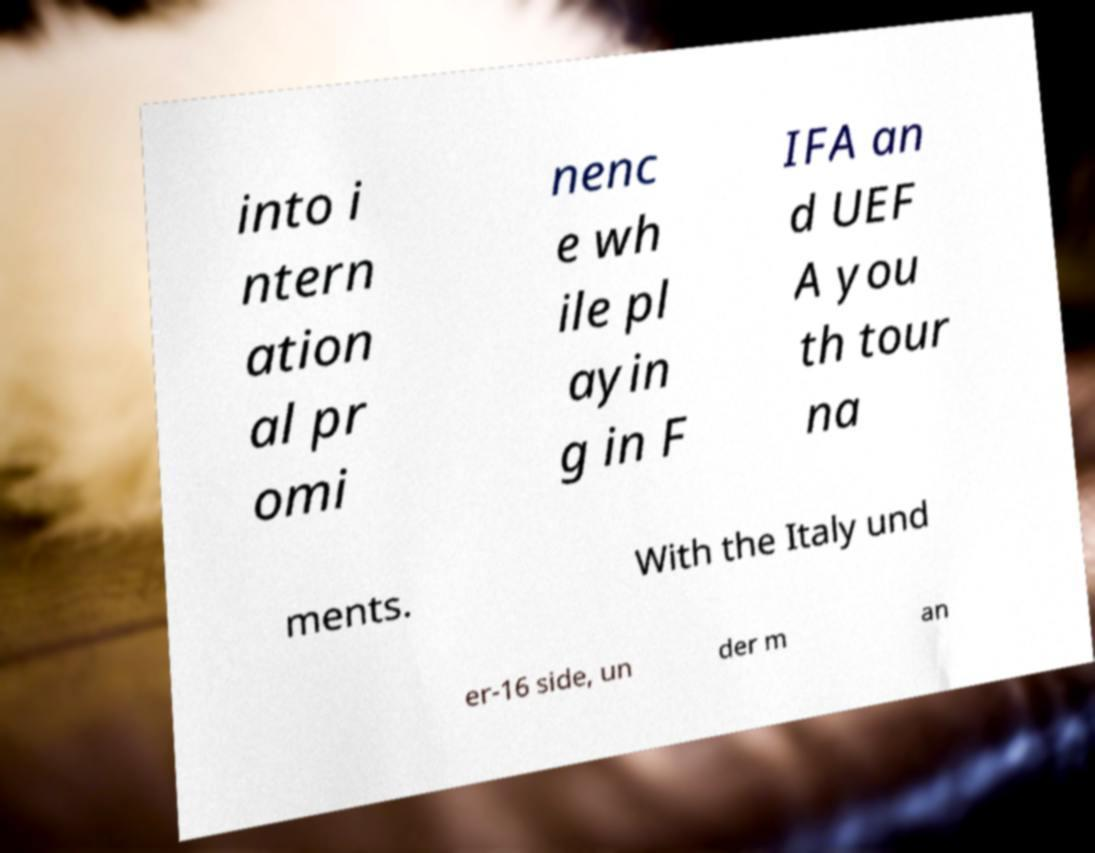There's text embedded in this image that I need extracted. Can you transcribe it verbatim? into i ntern ation al pr omi nenc e wh ile pl ayin g in F IFA an d UEF A you th tour na ments. With the Italy und er-16 side, un der m an 